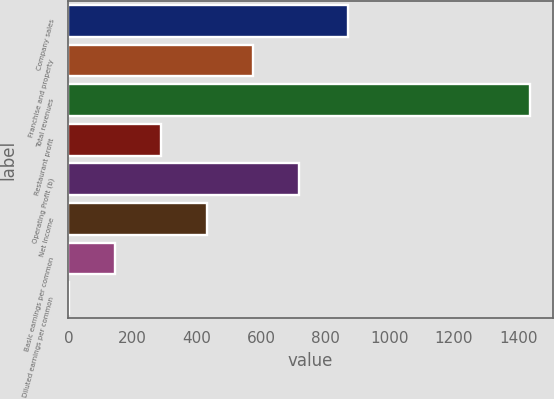<chart> <loc_0><loc_0><loc_500><loc_500><bar_chart><fcel>Company sales<fcel>Franchise and property<fcel>Total revenues<fcel>Restaurant profit<fcel>Operating Profit (b)<fcel>Net Income<fcel>Basic earnings per common<fcel>Diluted earnings per common<nl><fcel>871<fcel>575.1<fcel>1436<fcel>288.14<fcel>718.58<fcel>431.62<fcel>144.66<fcel>1.18<nl></chart> 